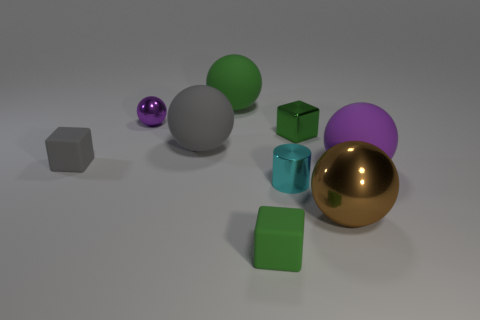Are there any patterns or consistencies in the arrangement of these objects? The objects seem to be arranged in a scattered, somewhat random fashion, without any clear pattern or symmetry. However, there is a mix of objects with smooth surfaces and those with flat surfaces, which provides visual contrast. What does the arrangement of these objects tell us about the space they're in? The space appears to be a neutral, non-descript environment, such as a studio set up for product photography or a virtual rendering space. The lack of distinctive features and shadows suggests the objects are not meant to convey a realistic scene but to allow focus on the objects themselves. 